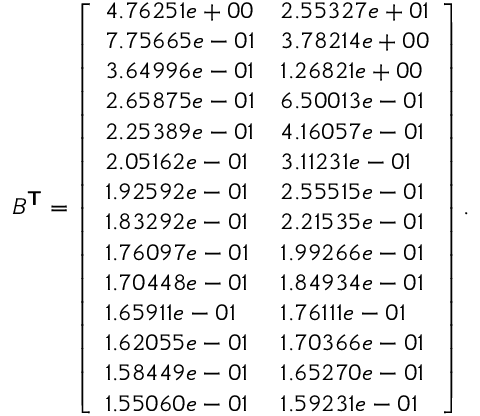Convert formula to latex. <formula><loc_0><loc_0><loc_500><loc_500>B ^ { T } = \left [ \begin{array} { l l } { 4 . 7 6 2 5 1 e + 0 0 } & { 2 . 5 5 3 2 7 e + 0 1 } \\ { 7 . 7 5 6 6 5 e - 0 1 } & { 3 . 7 8 2 1 4 e + 0 0 } \\ { 3 . 6 4 9 9 6 e - 0 1 } & { 1 . 2 6 8 2 1 e + 0 0 } \\ { 2 . 6 5 8 7 5 e - 0 1 } & { 6 . 5 0 0 1 3 e - 0 1 } \\ { 2 . 2 5 3 8 9 e - 0 1 } & { 4 . 1 6 0 5 7 e - 0 1 } \\ { 2 . 0 5 1 6 2 e - 0 1 } & { 3 . 1 1 2 3 1 e - 0 1 } \\ { 1 . 9 2 5 9 2 e - 0 1 } & { 2 . 5 5 5 1 5 e - 0 1 } \\ { 1 . 8 3 2 9 2 e - 0 1 } & { 2 . 2 1 5 3 5 e - 0 1 } \\ { 1 . 7 6 0 9 7 e - 0 1 } & { 1 . 9 9 2 6 6 e - 0 1 } \\ { 1 . 7 0 4 4 8 e - 0 1 } & { 1 . 8 4 9 3 4 e - 0 1 } \\ { 1 . 6 5 9 1 1 e - 0 1 } & { 1 . 7 6 1 1 1 e - 0 1 } \\ { 1 . 6 2 0 5 5 e - 0 1 } & { 1 . 7 0 3 6 6 e - 0 1 } \\ { 1 . 5 8 4 4 9 e - 0 1 } & { 1 . 6 5 2 7 0 e - 0 1 } \\ { 1 . 5 5 0 6 0 e - 0 1 } & { 1 . 5 9 2 3 1 e - 0 1 } \end{array} \right ] .</formula> 